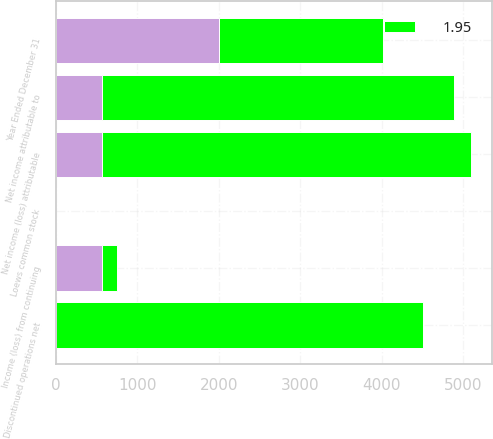Convert chart. <chart><loc_0><loc_0><loc_500><loc_500><stacked_bar_chart><ecel><fcel>Year Ended December 31<fcel>Income (loss) from continuing<fcel>Discontinued operations net<fcel>Net income attributable to<fcel>Net income (loss) attributable<fcel>Loews common stock<nl><fcel>nan<fcel>2009<fcel>566<fcel>2<fcel>564<fcel>564<fcel>1.3<nl><fcel>1.95<fcel>2008<fcel>182<fcel>4501<fcel>4319<fcel>4530<fcel>9.05<nl></chart> 